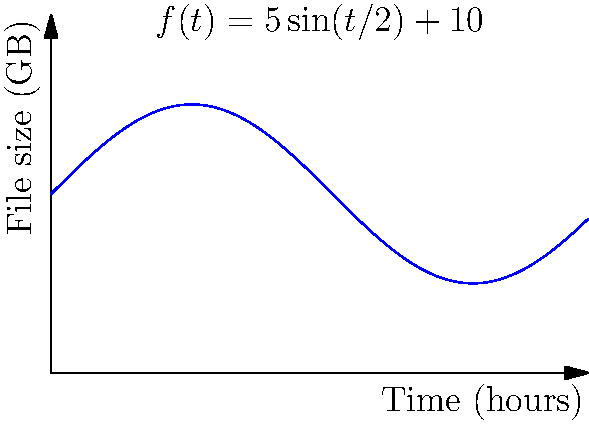As a videographer, you're working on a project where the file size of your video footage varies over time according to the function $f(t)=5\sin(t/2)+10$, where $f(t)$ is the file size in gigabytes (GB) and $t$ is the time in hours. Calculate the total amount of data storage needed for the entire 12-hour project by finding the area under the curve. To find the total amount of data storage needed, we need to calculate the integral of the given function over the 12-hour period. Here's how we can do this step-by-step:

1) The integral we need to calculate is:

   $$\int_0^{12} (5\sin(t/2)+10) dt$$

2) Let's break this into two parts:
   
   $$\int_0^{12} 5\sin(t/2) dt + \int_0^{12} 10 dt$$

3) For the first part, we can use the substitution method:
   Let $u = t/2$, then $du = \frac{1}{2}dt$ or $dt = 2du$
   When $t = 0$, $u = 0$; when $t = 12$, $u = 6$

   So, $\int_0^{12} 5\sin(t/2) dt = 10\int_0^6 \sin(u) du = -10\cos(u)|_0^6 = -10(\cos(6) - \cos(0)) = -10(\cos(6) - 1)$

4) The second part is straightforward:
   
   $$\int_0^{12} 10 dt = 10t|_0^{12} = 120$$

5) Adding the results from steps 3 and 4:

   Total storage = $-10(\cos(6) - 1) + 120$

6) Simplifying:
   
   $= -10\cos(6) + 10 + 120 = -10\cos(6) + 130$

7) Using a calculator to evaluate $\cos(6)$:

   $\approx -10(-0.96) + 130 = 9.6 + 130 = 139.6$
Answer: 139.6 GB 